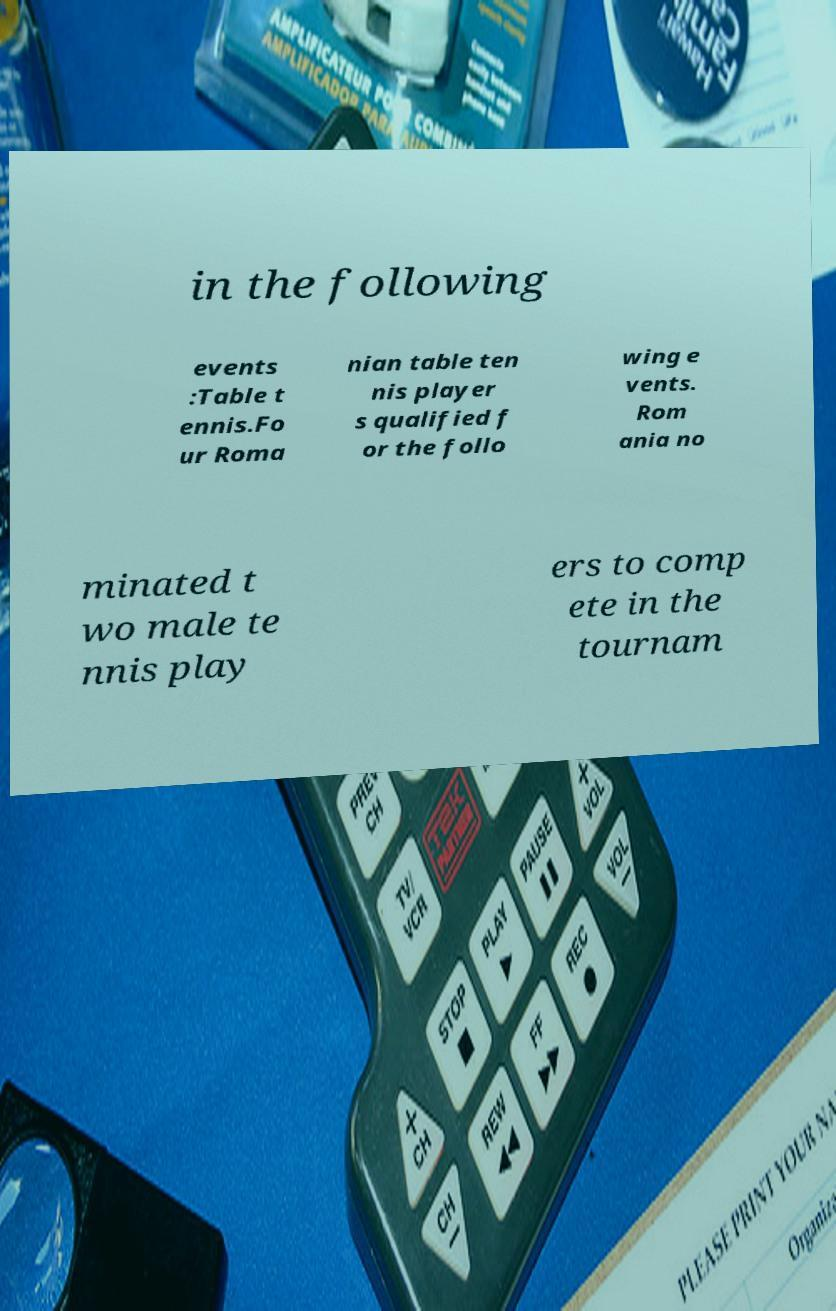Please read and relay the text visible in this image. What does it say? in the following events :Table t ennis.Fo ur Roma nian table ten nis player s qualified f or the follo wing e vents. Rom ania no minated t wo male te nnis play ers to comp ete in the tournam 